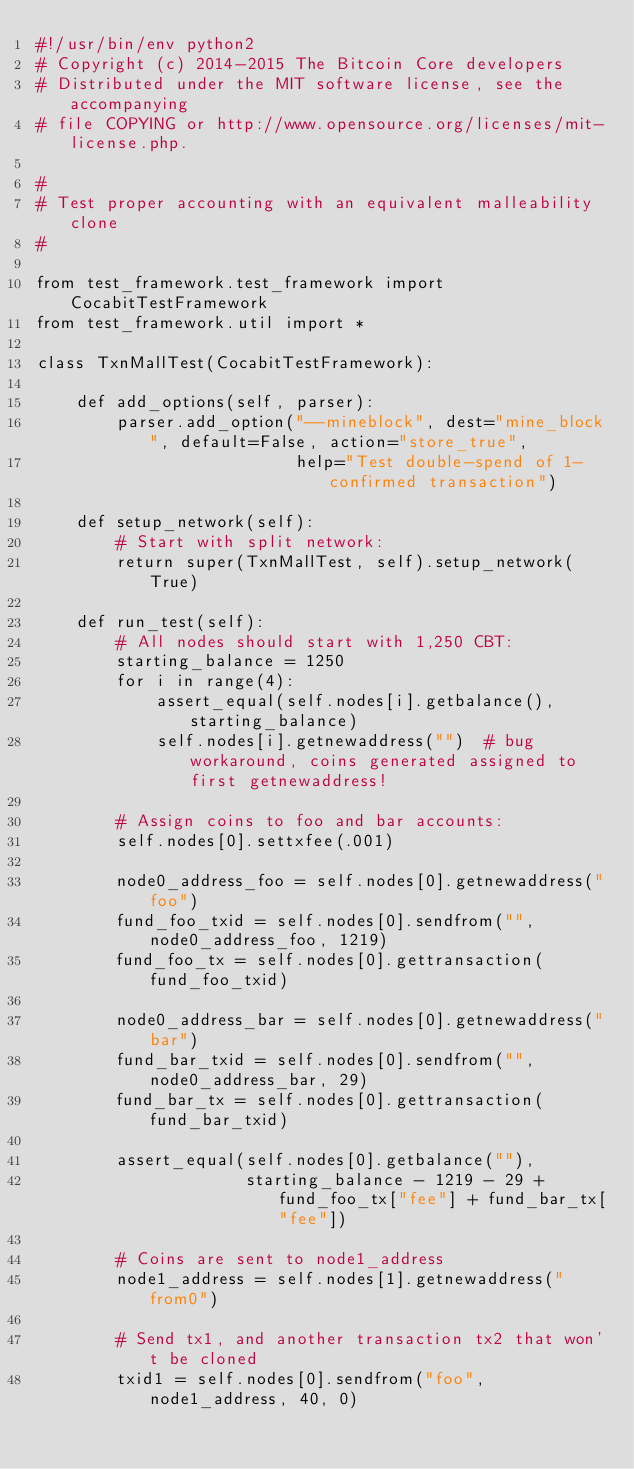Convert code to text. <code><loc_0><loc_0><loc_500><loc_500><_Python_>#!/usr/bin/env python2
# Copyright (c) 2014-2015 The Bitcoin Core developers
# Distributed under the MIT software license, see the accompanying
# file COPYING or http://www.opensource.org/licenses/mit-license.php.

#
# Test proper accounting with an equivalent malleability clone
#

from test_framework.test_framework import CocabitTestFramework
from test_framework.util import *

class TxnMallTest(CocabitTestFramework):

    def add_options(self, parser):
        parser.add_option("--mineblock", dest="mine_block", default=False, action="store_true",
                          help="Test double-spend of 1-confirmed transaction")

    def setup_network(self):
        # Start with split network:
        return super(TxnMallTest, self).setup_network(True)

    def run_test(self):
        # All nodes should start with 1,250 CBT:
        starting_balance = 1250
        for i in range(4):
            assert_equal(self.nodes[i].getbalance(), starting_balance)
            self.nodes[i].getnewaddress("")  # bug workaround, coins generated assigned to first getnewaddress!

        # Assign coins to foo and bar accounts:
        self.nodes[0].settxfee(.001)

        node0_address_foo = self.nodes[0].getnewaddress("foo")
        fund_foo_txid = self.nodes[0].sendfrom("", node0_address_foo, 1219)
        fund_foo_tx = self.nodes[0].gettransaction(fund_foo_txid)

        node0_address_bar = self.nodes[0].getnewaddress("bar")
        fund_bar_txid = self.nodes[0].sendfrom("", node0_address_bar, 29)
        fund_bar_tx = self.nodes[0].gettransaction(fund_bar_txid)

        assert_equal(self.nodes[0].getbalance(""),
                     starting_balance - 1219 - 29 + fund_foo_tx["fee"] + fund_bar_tx["fee"])

        # Coins are sent to node1_address
        node1_address = self.nodes[1].getnewaddress("from0")

        # Send tx1, and another transaction tx2 that won't be cloned 
        txid1 = self.nodes[0].sendfrom("foo", node1_address, 40, 0)</code> 